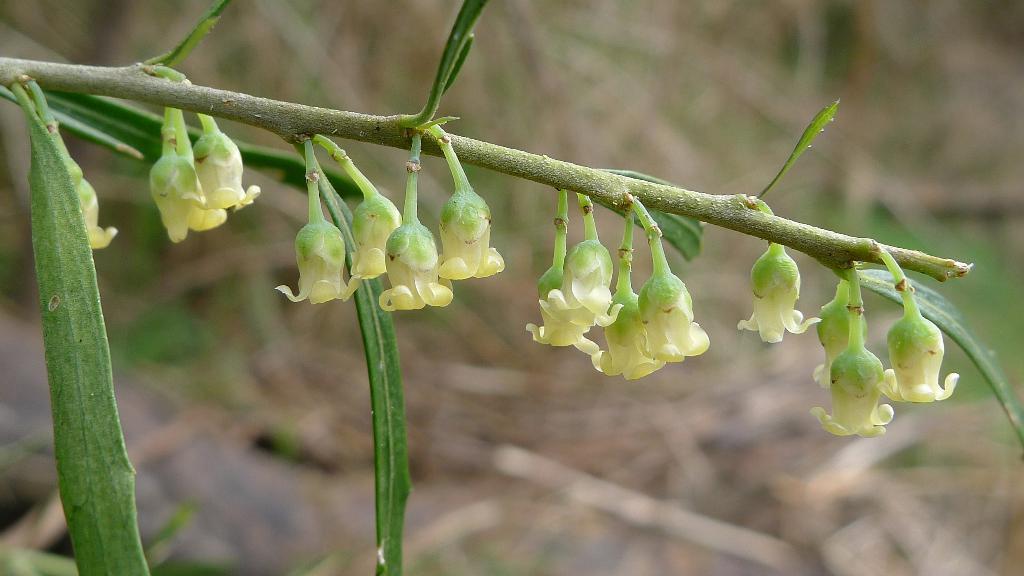Can you describe this image briefly? In the picture there is a branch of a plant and there are flower buds to the branch. 